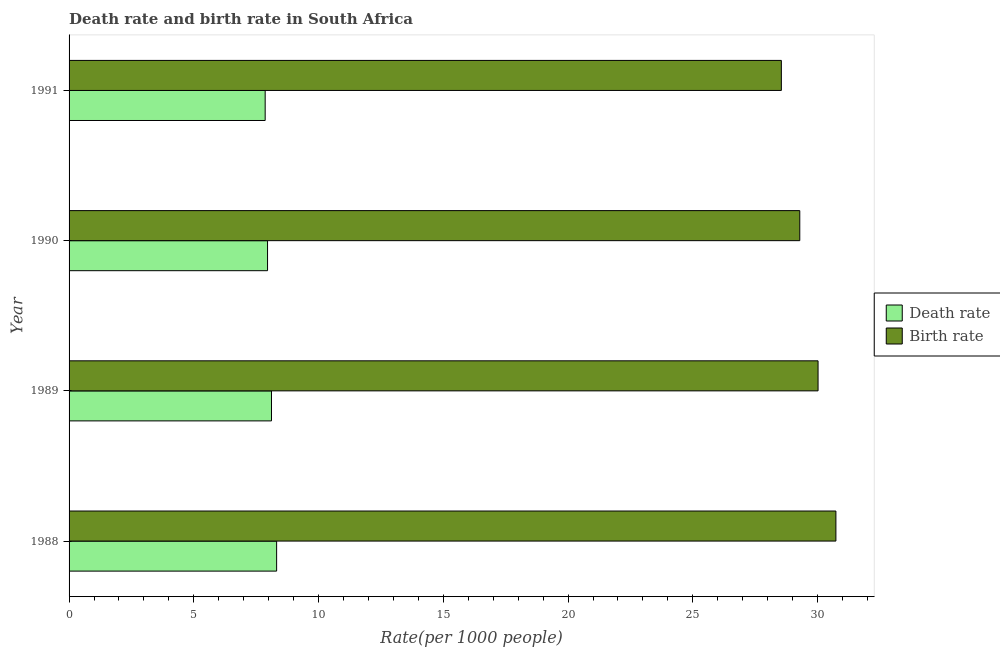Are the number of bars per tick equal to the number of legend labels?
Your answer should be compact. Yes. How many bars are there on the 2nd tick from the top?
Ensure brevity in your answer.  2. What is the label of the 1st group of bars from the top?
Provide a short and direct response. 1991. In how many cases, is the number of bars for a given year not equal to the number of legend labels?
Ensure brevity in your answer.  0. What is the death rate in 1991?
Keep it short and to the point. 7.86. Across all years, what is the maximum birth rate?
Your response must be concise. 30.73. Across all years, what is the minimum death rate?
Your response must be concise. 7.86. In which year was the birth rate maximum?
Offer a very short reply. 1988. What is the total death rate in the graph?
Provide a short and direct response. 32.25. What is the difference between the birth rate in 1989 and that in 1991?
Your response must be concise. 1.47. What is the difference between the birth rate in 1990 and the death rate in 1991?
Ensure brevity in your answer.  21.43. What is the average birth rate per year?
Your answer should be compact. 29.65. In the year 1990, what is the difference between the birth rate and death rate?
Give a very brief answer. 21.33. What is the ratio of the death rate in 1988 to that in 1989?
Your answer should be compact. 1.02. What is the difference between the highest and the second highest death rate?
Provide a succinct answer. 0.21. What is the difference between the highest and the lowest death rate?
Make the answer very short. 0.46. In how many years, is the death rate greater than the average death rate taken over all years?
Provide a succinct answer. 2. Is the sum of the birth rate in 1988 and 1990 greater than the maximum death rate across all years?
Offer a terse response. Yes. What does the 2nd bar from the top in 1990 represents?
Offer a terse response. Death rate. What does the 1st bar from the bottom in 1989 represents?
Your answer should be very brief. Death rate. How many bars are there?
Your answer should be compact. 8. What is the difference between two consecutive major ticks on the X-axis?
Offer a terse response. 5. How many legend labels are there?
Give a very brief answer. 2. How are the legend labels stacked?
Make the answer very short. Vertical. What is the title of the graph?
Make the answer very short. Death rate and birth rate in South Africa. What is the label or title of the X-axis?
Offer a terse response. Rate(per 1000 people). What is the label or title of the Y-axis?
Offer a terse response. Year. What is the Rate(per 1000 people) in Death rate in 1988?
Ensure brevity in your answer.  8.32. What is the Rate(per 1000 people) in Birth rate in 1988?
Provide a short and direct response. 30.73. What is the Rate(per 1000 people) of Death rate in 1989?
Provide a short and direct response. 8.11. What is the Rate(per 1000 people) in Birth rate in 1989?
Offer a very short reply. 30.02. What is the Rate(per 1000 people) in Death rate in 1990?
Your answer should be very brief. 7.96. What is the Rate(per 1000 people) of Birth rate in 1990?
Your answer should be very brief. 29.29. What is the Rate(per 1000 people) of Death rate in 1991?
Keep it short and to the point. 7.86. What is the Rate(per 1000 people) in Birth rate in 1991?
Keep it short and to the point. 28.55. Across all years, what is the maximum Rate(per 1000 people) in Death rate?
Your answer should be very brief. 8.32. Across all years, what is the maximum Rate(per 1000 people) in Birth rate?
Offer a very short reply. 30.73. Across all years, what is the minimum Rate(per 1000 people) of Death rate?
Keep it short and to the point. 7.86. Across all years, what is the minimum Rate(per 1000 people) of Birth rate?
Give a very brief answer. 28.55. What is the total Rate(per 1000 people) of Death rate in the graph?
Make the answer very short. 32.25. What is the total Rate(per 1000 people) of Birth rate in the graph?
Your answer should be very brief. 118.59. What is the difference between the Rate(per 1000 people) of Death rate in 1988 and that in 1989?
Give a very brief answer. 0.21. What is the difference between the Rate(per 1000 people) in Birth rate in 1988 and that in 1989?
Offer a very short reply. 0.71. What is the difference between the Rate(per 1000 people) in Death rate in 1988 and that in 1990?
Make the answer very short. 0.36. What is the difference between the Rate(per 1000 people) in Birth rate in 1988 and that in 1990?
Keep it short and to the point. 1.45. What is the difference between the Rate(per 1000 people) in Death rate in 1988 and that in 1991?
Make the answer very short. 0.46. What is the difference between the Rate(per 1000 people) of Birth rate in 1988 and that in 1991?
Make the answer very short. 2.19. What is the difference between the Rate(per 1000 people) in Death rate in 1989 and that in 1990?
Offer a very short reply. 0.16. What is the difference between the Rate(per 1000 people) in Birth rate in 1989 and that in 1990?
Your answer should be compact. 0.73. What is the difference between the Rate(per 1000 people) of Death rate in 1989 and that in 1991?
Offer a very short reply. 0.25. What is the difference between the Rate(per 1000 people) in Birth rate in 1989 and that in 1991?
Make the answer very short. 1.47. What is the difference between the Rate(per 1000 people) of Death rate in 1990 and that in 1991?
Keep it short and to the point. 0.1. What is the difference between the Rate(per 1000 people) of Birth rate in 1990 and that in 1991?
Your answer should be very brief. 0.74. What is the difference between the Rate(per 1000 people) in Death rate in 1988 and the Rate(per 1000 people) in Birth rate in 1989?
Offer a terse response. -21.7. What is the difference between the Rate(per 1000 people) in Death rate in 1988 and the Rate(per 1000 people) in Birth rate in 1990?
Make the answer very short. -20.97. What is the difference between the Rate(per 1000 people) of Death rate in 1988 and the Rate(per 1000 people) of Birth rate in 1991?
Keep it short and to the point. -20.23. What is the difference between the Rate(per 1000 people) of Death rate in 1989 and the Rate(per 1000 people) of Birth rate in 1990?
Your answer should be compact. -21.17. What is the difference between the Rate(per 1000 people) of Death rate in 1989 and the Rate(per 1000 people) of Birth rate in 1991?
Keep it short and to the point. -20.44. What is the difference between the Rate(per 1000 people) of Death rate in 1990 and the Rate(per 1000 people) of Birth rate in 1991?
Your response must be concise. -20.59. What is the average Rate(per 1000 people) in Death rate per year?
Provide a succinct answer. 8.06. What is the average Rate(per 1000 people) of Birth rate per year?
Make the answer very short. 29.65. In the year 1988, what is the difference between the Rate(per 1000 people) in Death rate and Rate(per 1000 people) in Birth rate?
Offer a terse response. -22.42. In the year 1989, what is the difference between the Rate(per 1000 people) of Death rate and Rate(per 1000 people) of Birth rate?
Your answer should be very brief. -21.91. In the year 1990, what is the difference between the Rate(per 1000 people) in Death rate and Rate(per 1000 people) in Birth rate?
Keep it short and to the point. -21.33. In the year 1991, what is the difference between the Rate(per 1000 people) in Death rate and Rate(per 1000 people) in Birth rate?
Your answer should be compact. -20.69. What is the ratio of the Rate(per 1000 people) of Death rate in 1988 to that in 1989?
Provide a succinct answer. 1.03. What is the ratio of the Rate(per 1000 people) of Birth rate in 1988 to that in 1989?
Your response must be concise. 1.02. What is the ratio of the Rate(per 1000 people) in Death rate in 1988 to that in 1990?
Give a very brief answer. 1.05. What is the ratio of the Rate(per 1000 people) of Birth rate in 1988 to that in 1990?
Give a very brief answer. 1.05. What is the ratio of the Rate(per 1000 people) of Death rate in 1988 to that in 1991?
Make the answer very short. 1.06. What is the ratio of the Rate(per 1000 people) in Birth rate in 1988 to that in 1991?
Provide a succinct answer. 1.08. What is the ratio of the Rate(per 1000 people) of Death rate in 1989 to that in 1990?
Provide a succinct answer. 1.02. What is the ratio of the Rate(per 1000 people) of Birth rate in 1989 to that in 1990?
Provide a short and direct response. 1.02. What is the ratio of the Rate(per 1000 people) of Death rate in 1989 to that in 1991?
Provide a short and direct response. 1.03. What is the ratio of the Rate(per 1000 people) of Birth rate in 1989 to that in 1991?
Give a very brief answer. 1.05. What is the ratio of the Rate(per 1000 people) of Death rate in 1990 to that in 1991?
Ensure brevity in your answer.  1.01. What is the ratio of the Rate(per 1000 people) in Birth rate in 1990 to that in 1991?
Ensure brevity in your answer.  1.03. What is the difference between the highest and the second highest Rate(per 1000 people) of Death rate?
Your response must be concise. 0.21. What is the difference between the highest and the second highest Rate(per 1000 people) of Birth rate?
Offer a very short reply. 0.71. What is the difference between the highest and the lowest Rate(per 1000 people) in Death rate?
Keep it short and to the point. 0.46. What is the difference between the highest and the lowest Rate(per 1000 people) in Birth rate?
Provide a short and direct response. 2.19. 